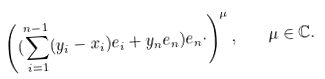<formula> <loc_0><loc_0><loc_500><loc_500>\left ( ( \sum _ { i = 1 } ^ { n - 1 } ( y _ { i } - x _ { i } ) e _ { i } + y _ { n } e _ { n } ) e _ { n } \cdot \right ) ^ { \mu } , \quad \mu \in { \mathbb { C } } .</formula> 